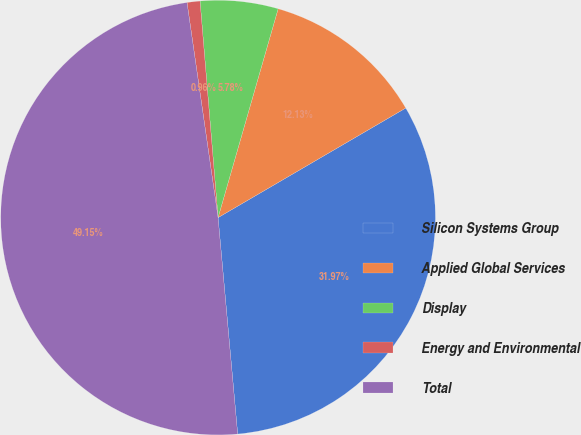Convert chart to OTSL. <chart><loc_0><loc_0><loc_500><loc_500><pie_chart><fcel>Silicon Systems Group<fcel>Applied Global Services<fcel>Display<fcel>Energy and Environmental<fcel>Total<nl><fcel>31.97%<fcel>12.13%<fcel>5.78%<fcel>0.96%<fcel>49.15%<nl></chart> 